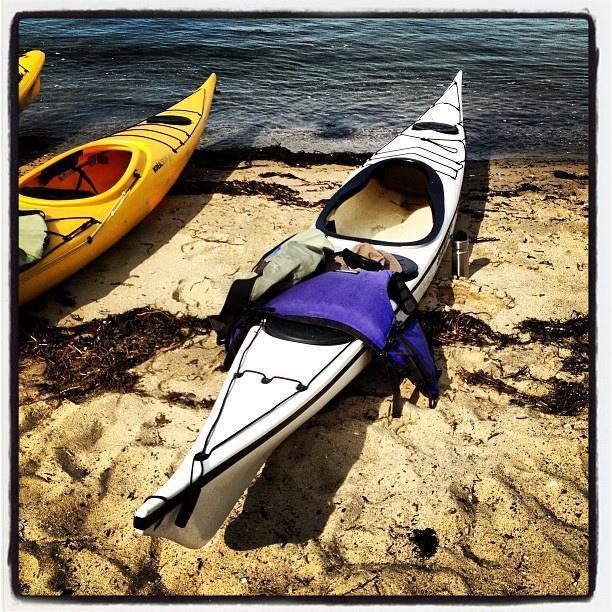How many boats are there?
Give a very brief answer. 2. How many people are to the left of the man with an umbrella over his head?
Give a very brief answer. 0. 